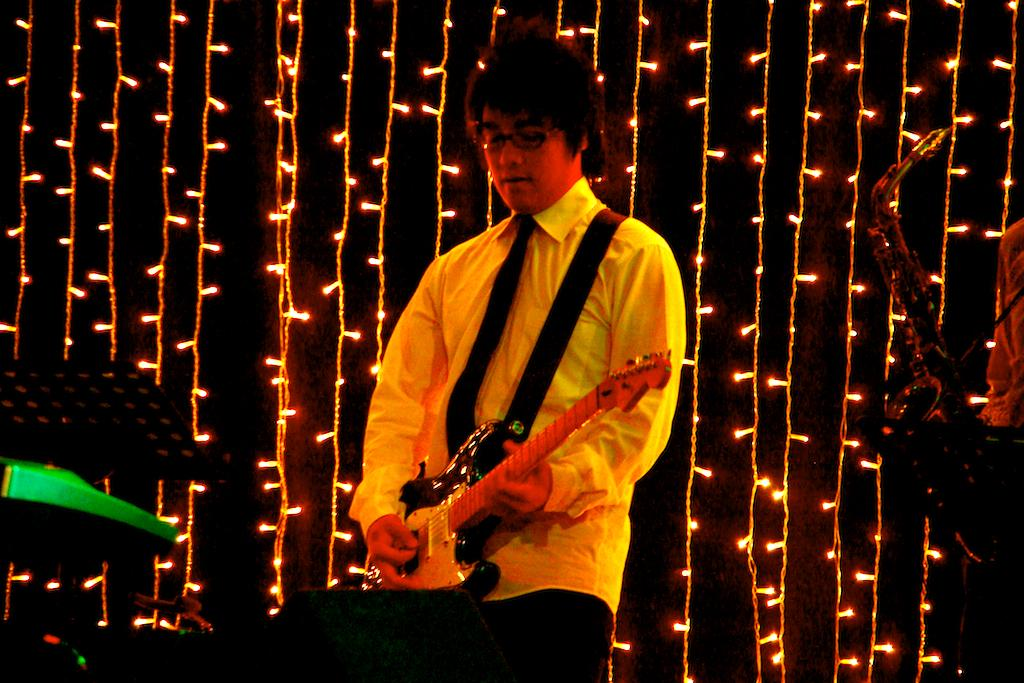What is the main activity taking place in the image? There is a person playing the guitar and another person playing a saxophone in the image. Can you describe the instruments being played? One person is playing the guitar, and the other person is playing a saxophone. What can be seen in the background of the image? There are beautiful lights in the background of the image. What is the title of the song being played by the person with the toe in the image? There is no person with a toe mentioned in the image, and no song title is provided. 